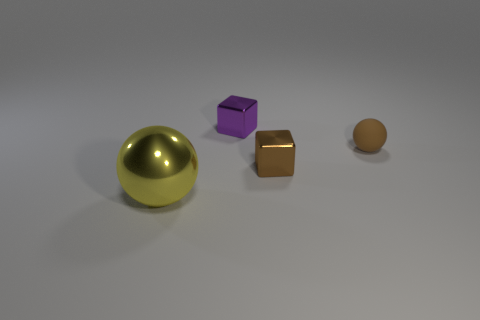Add 4 blocks. How many objects exist? 8 Subtract 0 purple spheres. How many objects are left? 4 Subtract all small balls. Subtract all tiny green objects. How many objects are left? 3 Add 1 tiny shiny cubes. How many tiny shiny cubes are left? 3 Add 3 cubes. How many cubes exist? 5 